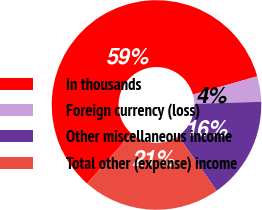Convert chart to OTSL. <chart><loc_0><loc_0><loc_500><loc_500><pie_chart><fcel>In thousands<fcel>Foreign currency (loss)<fcel>Other miscellaneous income<fcel>Total other (expense) income<nl><fcel>59.08%<fcel>3.93%<fcel>15.74%<fcel>21.25%<nl></chart> 